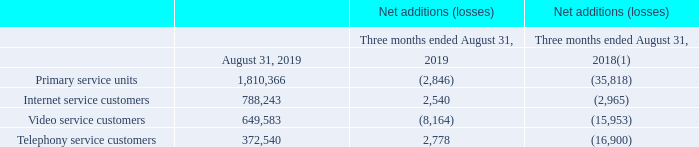(1) Exclude adjustments related to the migration to the new customer management system implemented during the third quarter of fiscal 2018.
During the third quarter of fiscal 2018, the Canadian broadband services segment implemented a new customer management system, replacing 22 legacy systems. While the customer management system was still in the stabilization phase, contact center congestion resulted in lower services activations during most of the fourth quarter of fiscal 2018. Contact center and marketing operations had returned to normal at the end of the first quarter of 2019.
Variations of each services are also explained as follows:
INTERNET Fiscal 2019 fourth-quarter Internet service customers net additions stood at 2,540 compared to net losses of 2,965 for the same period of the prior year mainly due to: • the ongoing interest in high speed offerings; • the sustained interest in bundle offers; and • the increased demand from Internet resellers; partly offset by • competitive offers in the industry.
VIDEO Fiscal 2019 fourth-quarter video service customers net losses stood at 8,164 compared to 15,953 for the same period of the prior year as a result of: • highly competitive offers in the industry; and • a changing video consumption environment; partly offset by • customers' ongoing interest in digital advanced video services; and • customers' interest in video services bundled with fast Internet offerings.
TELEPHONY Fiscal 2019 fourth-quarter telephony service customers net additions amounted to 2,778 compared to net losses 16,900 for the same period of the prior year mainly due to: • more telephony bundles due to additional promotional activity in the second half of fiscal 2019; and • growth in the business sector; partly offset by • increasing wireless penetration in North America and various unlimited offers launched by wireless operators causing some customers to cancel their landline telephony services for wireless telephony services only.
Why did the Fiscal 2019 fourth-quarter Internet service customers net additions stood at 2,540 compared to net losses of 2,965 for the same period of the prior year? • the ongoing interest in high speed offerings; • the sustained interest in bundle offers; and • the increased demand from internet resellers; partly offset by • competitive offers in the industry. Why did the Fiscal 2019 fourth-quarter video service customers net losses stood at 8,164 compared to 15,953 for the same period of the prior year? • highly competitive offers in the industry; and • a changing video consumption environment; partly offset by • customers' ongoing interest in digital advanced video services; and • customers' interest in video services bundled with fast internet offerings. Why did the Fiscal 2019 fourth-quarter telephony service customers net additions amounted to 2,778 compared to net losses 16,900 for the same period of the prior year? • more telephony bundles due to additional promotional activity in the second half of fiscal 2019; and • growth in the business sector; partly offset by • increasing wireless penetration in north america and various unlimited offers launched by wireless operators causing some customers to cancel their landline telephony services for wireless telephony services only. What is the increase/ (decrease) Primary service units of Net additions (losses) from 2018 to 2019? (-2,846)-(-35,818)
Answer: 32972. What is the increase/ (decrease) Internet service customers of Net additions (losses) from 2018 to 2019? 2,540-(-2,965)
Answer: 5505. What is the increase/ (decrease) Video service customers of Net additions (losses) from 2018 to 2019? (-8,164)-(-15,953)
Answer: 7789. 